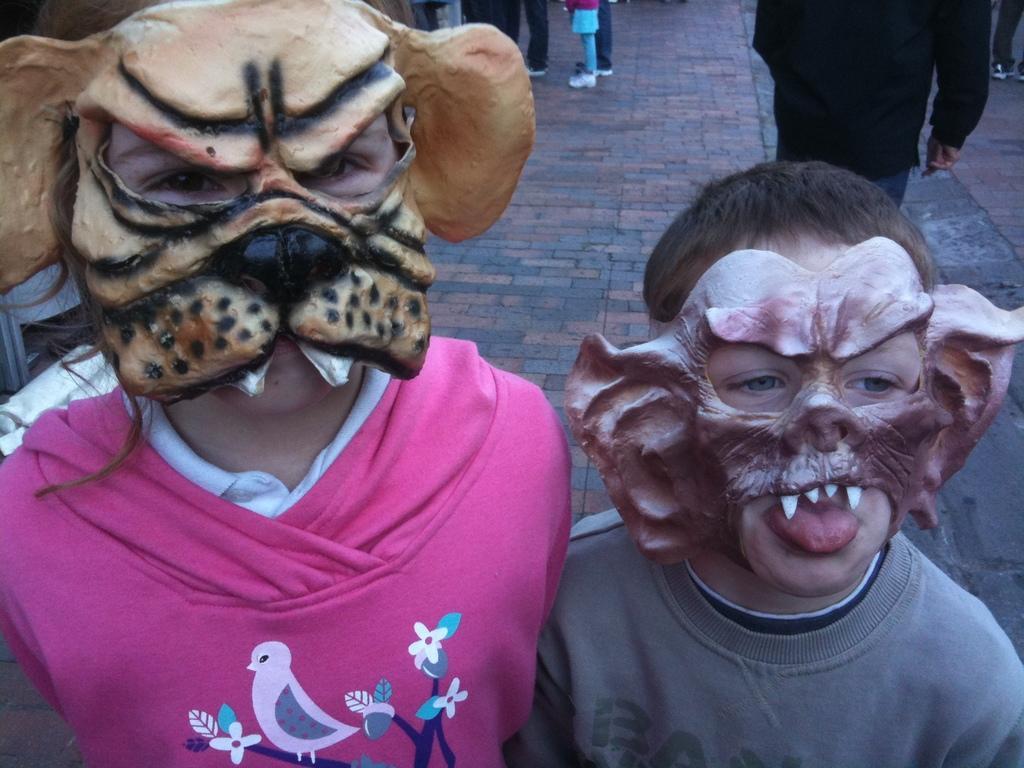Describe this image in one or two sentences. Here in this picture we can see two children present on the ground over there and both of them are wearing face masks on them and behind them also we can see number of people standing on the ground over there. 